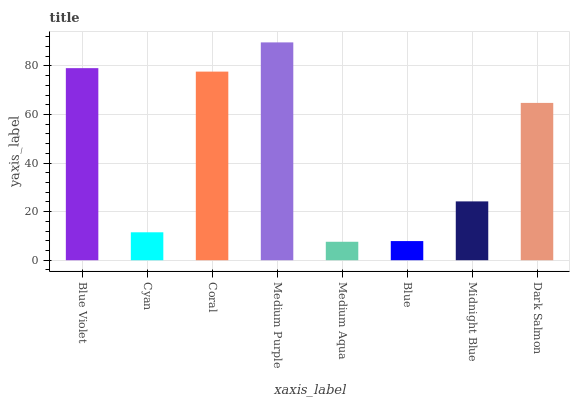Is Medium Aqua the minimum?
Answer yes or no. Yes. Is Medium Purple the maximum?
Answer yes or no. Yes. Is Cyan the minimum?
Answer yes or no. No. Is Cyan the maximum?
Answer yes or no. No. Is Blue Violet greater than Cyan?
Answer yes or no. Yes. Is Cyan less than Blue Violet?
Answer yes or no. Yes. Is Cyan greater than Blue Violet?
Answer yes or no. No. Is Blue Violet less than Cyan?
Answer yes or no. No. Is Dark Salmon the high median?
Answer yes or no. Yes. Is Midnight Blue the low median?
Answer yes or no. Yes. Is Medium Purple the high median?
Answer yes or no. No. Is Cyan the low median?
Answer yes or no. No. 